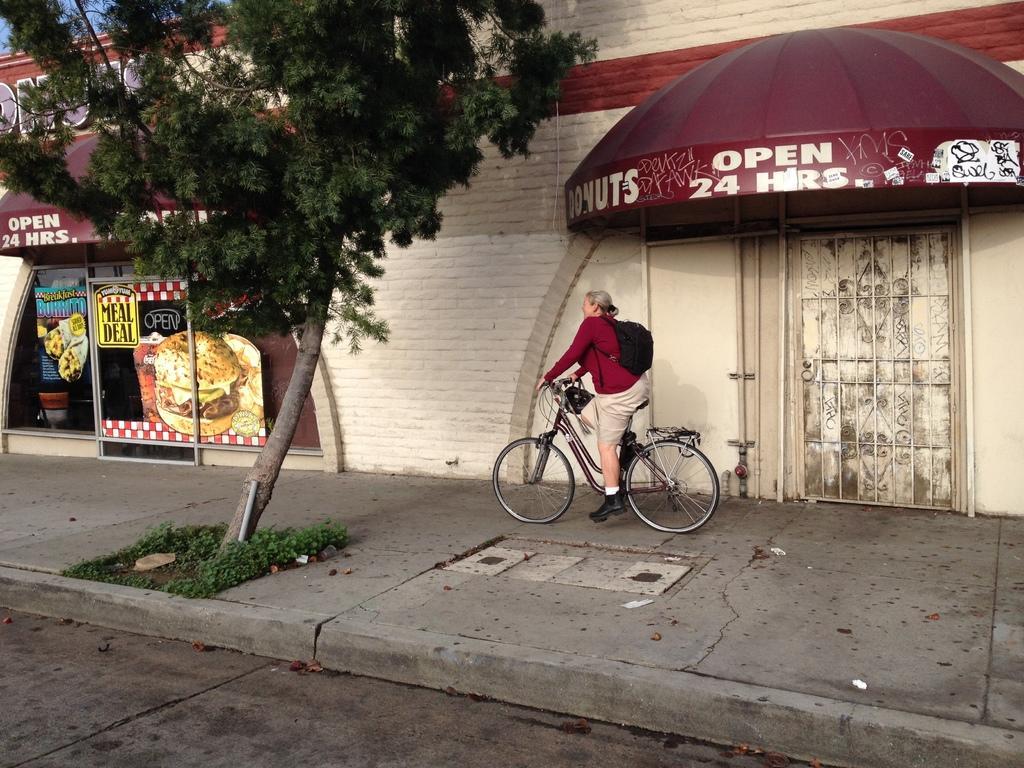In one or two sentences, can you explain what this image depicts? There is a woman in the picture wearing a red t shirt riding a bicycle on the footpath. There is a tree and some plants under the tree. We can observe a wall and a shop here in the background. The woman is holding the bag on her back. 